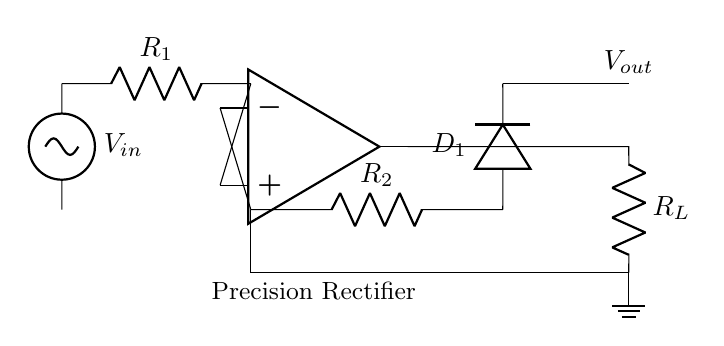What is the power supply voltage? The diagram shows a voltage source labeled \( V_{in} \) on the left side. The exact voltage isn't specified in the diagram, indicating it might be defined elsewhere or in a practical context.
Answer: Not specified What components are used in the feedback loop? The feedback loop includes a resistor \( R_2 \) and a diode \( D_1 \). They are connected from the output of the op-amp back to its inverting input, creating the feedback needed for the precision rectification.
Answer: Resistor \( R_2 \) and Diode \( D_1 \) What is the role of the operational amplifier? The operational amplifier is primarily used to amplify the input signal to provide greater output precision in the rectifying process. It helps control the voltage levels in the feedback loop, making the circuit act as a precision rectifier.
Answer: Amplification What is the output voltage connection? The output voltage, labeled \( V_{out} \), is connected from the output of the operational amplifier to the load resistor \( R_L \), which is then grounded. This setup indicates that \( V_{out} \) reflects the processed signal from the input.
Answer: Connected to \( R_L \) What happens to negative input signals in this circuit? In a precision rectifier circuit, negative input signals are effectively removed or converted to a positive output signal due to the behavior of the diode \( D_1 \) when the op-amp is configured this way, allowing only positive voltages to pass.
Answer: Converted to positive What are the values needed for \( R_1 \) and \( R_2 \) for accurate rectification? The values for \( R_1 \) and \( R_2 \) must be selected based on desired gain and signal handling characteristics of the circuit. While their specific values are not given in the diagram, they are typically chosen to match the application needs.
Answer: Application-specific 